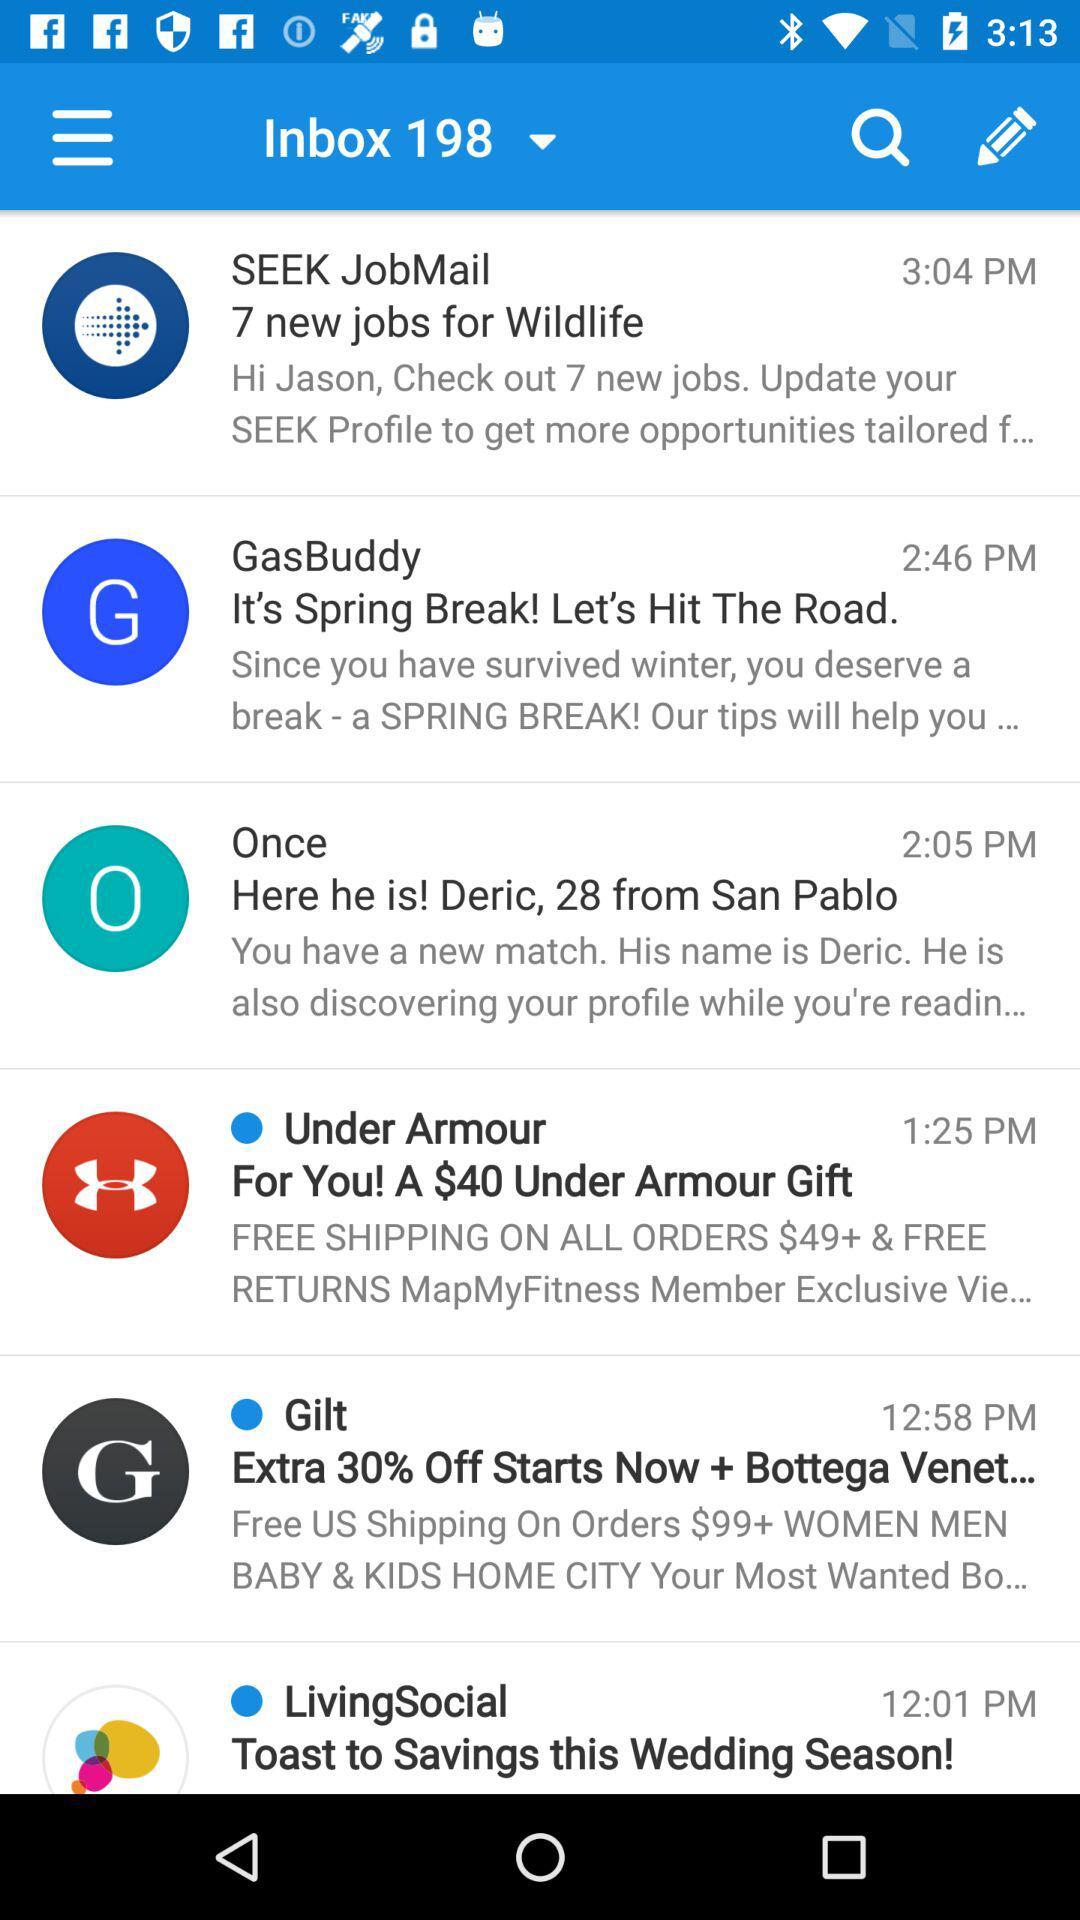What is the time for "Once" mail? The time is 2:05 PM. 